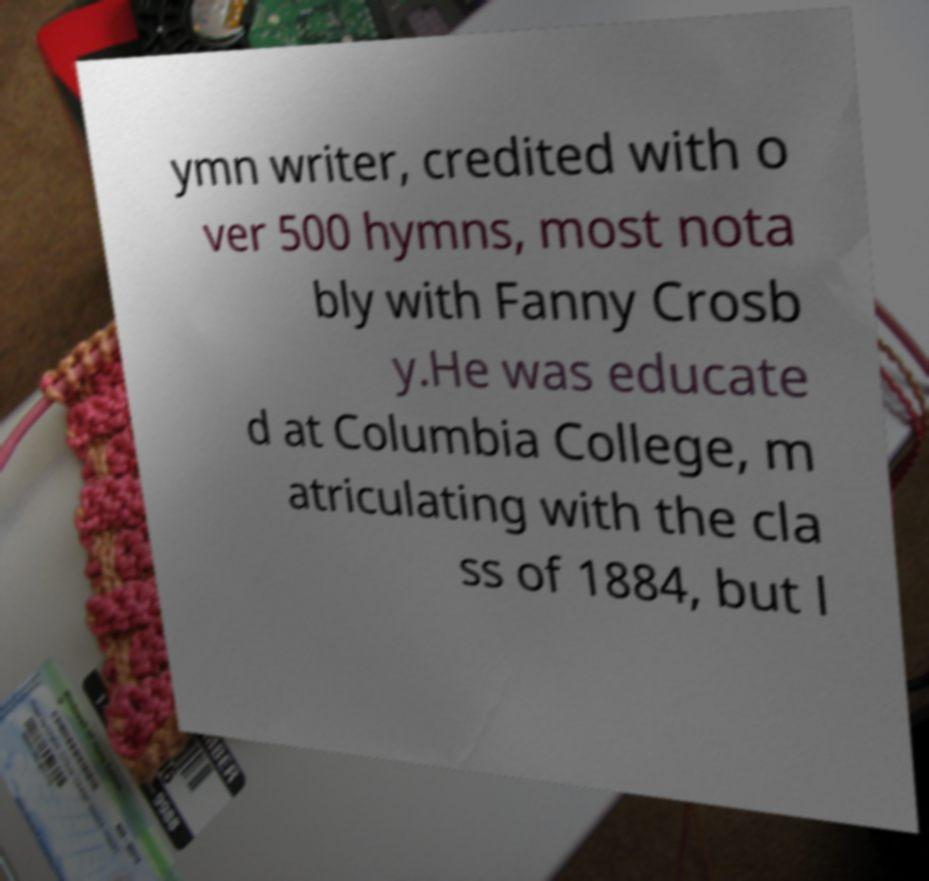I need the written content from this picture converted into text. Can you do that? ymn writer, credited with o ver 500 hymns, most nota bly with Fanny Crosb y.He was educate d at Columbia College, m atriculating with the cla ss of 1884, but l 